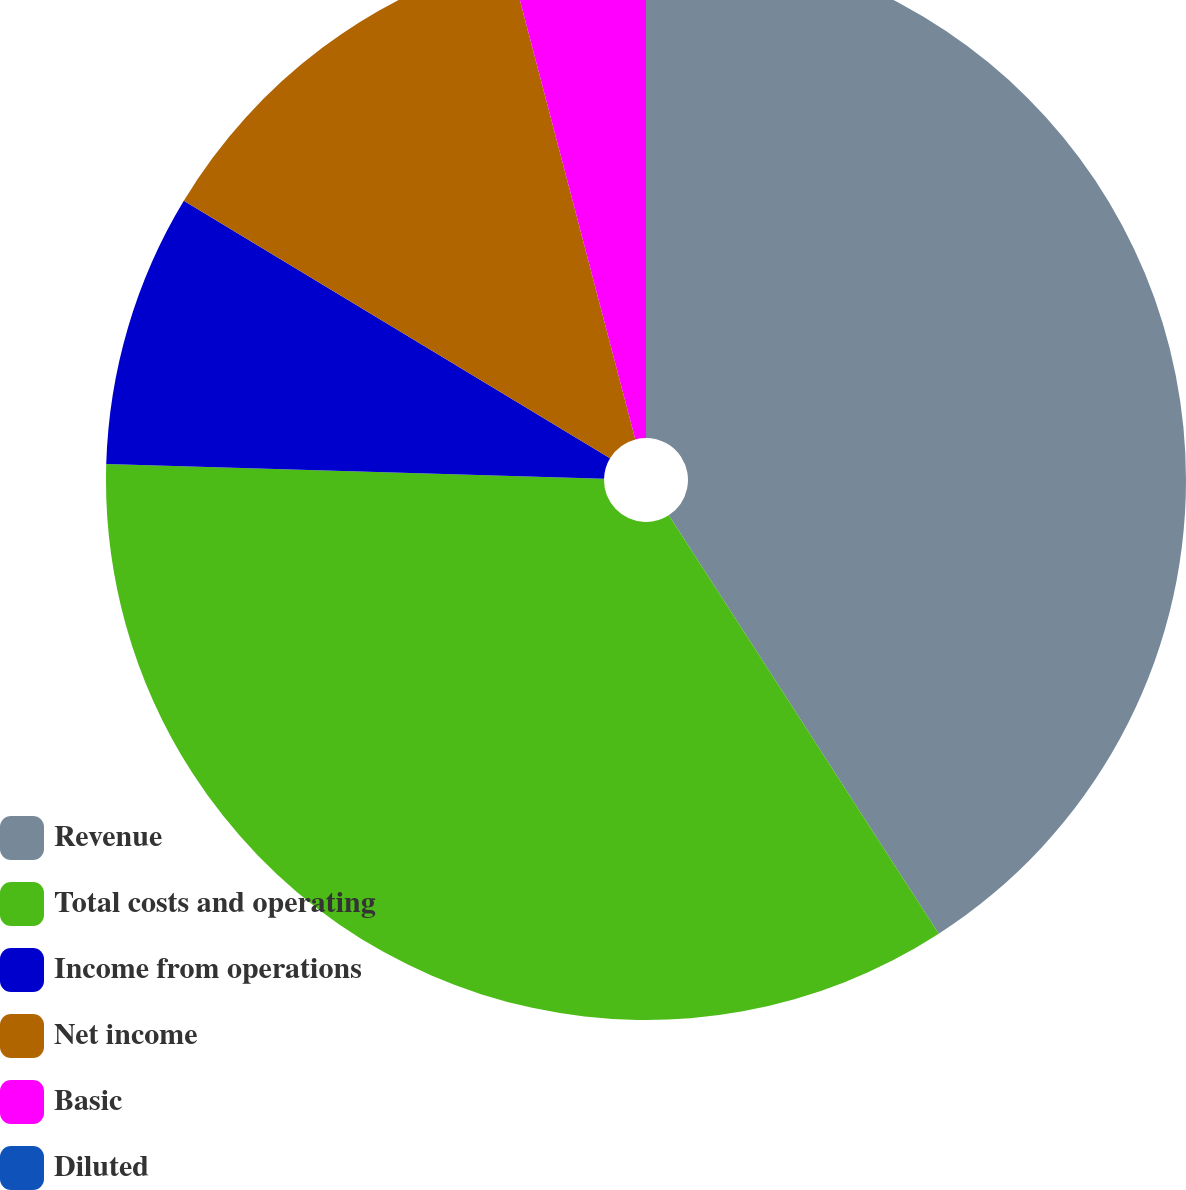Convert chart. <chart><loc_0><loc_0><loc_500><loc_500><pie_chart><fcel>Revenue<fcel>Total costs and operating<fcel>Income from operations<fcel>Net income<fcel>Basic<fcel>Diluted<nl><fcel>40.88%<fcel>34.59%<fcel>8.18%<fcel>12.26%<fcel>4.09%<fcel>0.0%<nl></chart> 